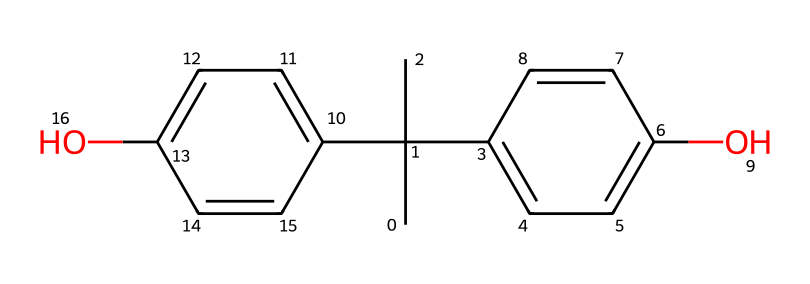What is the molecular formula of bisphenol A? To find the molecular formula, we need to count the number of each type of atom from the chemical structure. From the SMILES notation, we can identify the carbon (C) and oxygen (O) atoms. There are 15 carbons and 2 oxygens. Hence, the molecular formula is C15H16O2.
Answer: C15H16O2 How many hydroxyl (-OH) groups are present in bisphenol A? By analyzing the structure, we can locate the hydroxyl groups. The presence of 'O' in the given SMILES indicates that there are 2 hydroxyl groups attached to the phenolic rings. Therefore, bisphenol A has 2 hydroxyl groups.
Answer: 2 What type of chemical compound is bisphenol A? Bisphenol A is known as a phenolic compound due to the presence of the hydroxyl groups attached to aromatic rings in its structure.
Answer: phenolic What is the significance of the phenolic structure in bisphenol A? The phenolic structure provides bisphenol A with chemical properties important for polymer production, such as increasing the thermal stability of plastics. This is mainly because the resonance stabilization in the aromatic rings helps maintain stability against thermal degradation.
Answer: thermal stability How many rings are present in the molecular structure of bisphenol A? Inspecting the chemical structure, we can identify that bisphenol A consists of 2 benzene rings which are connected by a carbon chain. Therefore, there are a total of 2 rings present in its structure.
Answer: 2 